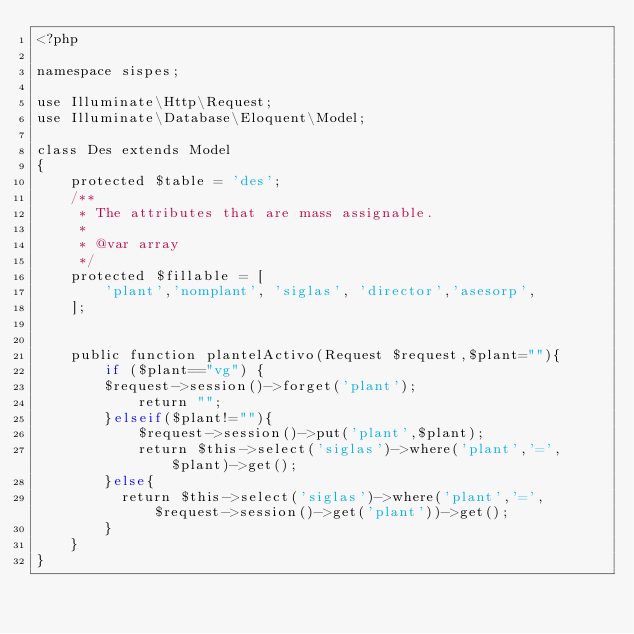<code> <loc_0><loc_0><loc_500><loc_500><_PHP_><?php

namespace sispes;

use Illuminate\Http\Request;
use Illuminate\Database\Eloquent\Model;

class Des extends Model
{
    protected $table = 'des';
    /**
     * The attributes that are mass assignable.
     *
     * @var array
     */
    protected $fillable = [
        'plant','nomplant', 'siglas', 'director','asesorp',
    ];

    
    public function plantelActivo(Request $request,$plant=""){
        if ($plant=="vg") {
    		$request->session()->forget('plant');
            return "";	            
        }elseif($plant!=""){
            $request->session()->put('plant',$plant);
            return $this->select('siglas')->where('plant','=',$plant)->get();
        }else{
        	return $this->select('siglas')->where('plant','=',$request->session()->get('plant'))->get();
        }
    }
}
</code> 